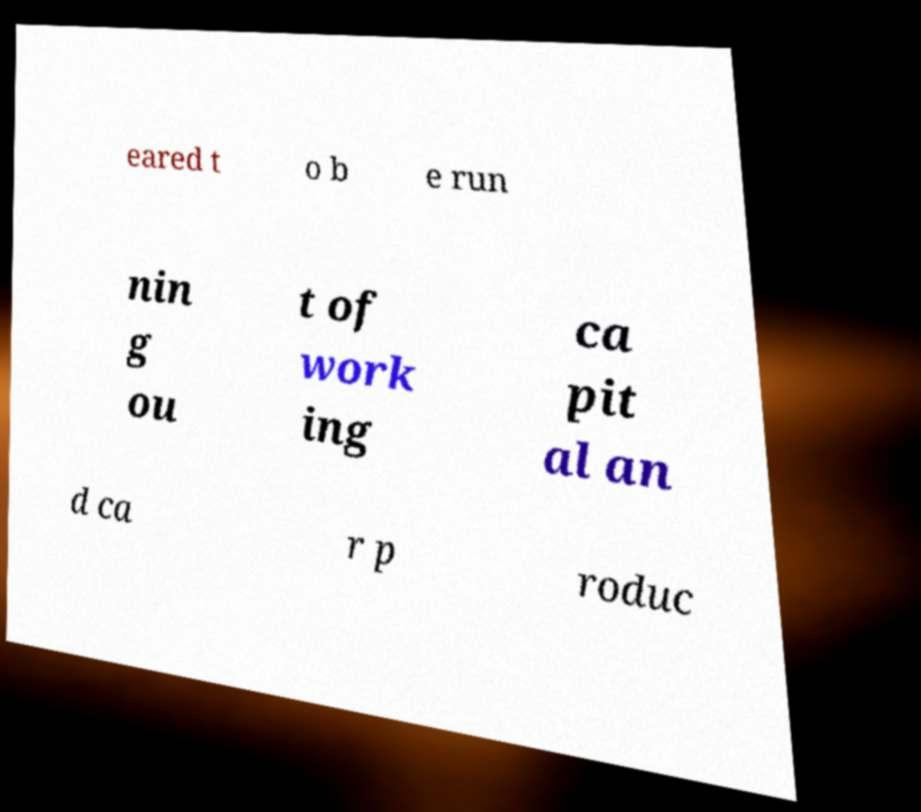Can you read and provide the text displayed in the image?This photo seems to have some interesting text. Can you extract and type it out for me? eared t o b e run nin g ou t of work ing ca pit al an d ca r p roduc 